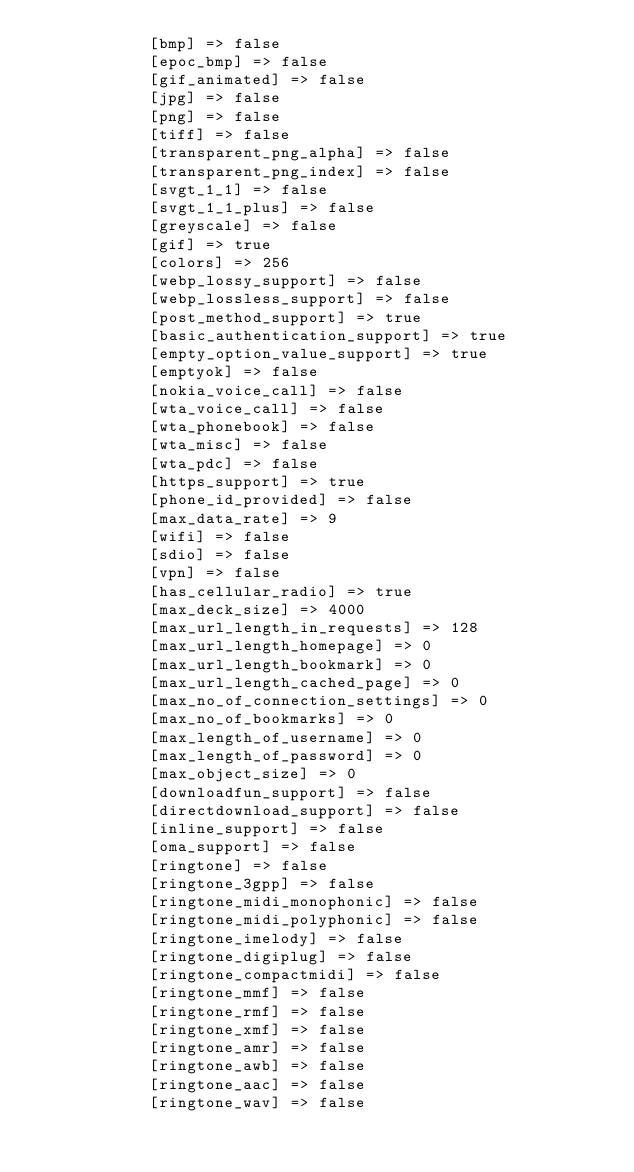<code> <loc_0><loc_0><loc_500><loc_500><_HTML_>            [bmp] => false
            [epoc_bmp] => false
            [gif_animated] => false
            [jpg] => false
            [png] => false
            [tiff] => false
            [transparent_png_alpha] => false
            [transparent_png_index] => false
            [svgt_1_1] => false
            [svgt_1_1_plus] => false
            [greyscale] => false
            [gif] => true
            [colors] => 256
            [webp_lossy_support] => false
            [webp_lossless_support] => false
            [post_method_support] => true
            [basic_authentication_support] => true
            [empty_option_value_support] => true
            [emptyok] => false
            [nokia_voice_call] => false
            [wta_voice_call] => false
            [wta_phonebook] => false
            [wta_misc] => false
            [wta_pdc] => false
            [https_support] => true
            [phone_id_provided] => false
            [max_data_rate] => 9
            [wifi] => false
            [sdio] => false
            [vpn] => false
            [has_cellular_radio] => true
            [max_deck_size] => 4000
            [max_url_length_in_requests] => 128
            [max_url_length_homepage] => 0
            [max_url_length_bookmark] => 0
            [max_url_length_cached_page] => 0
            [max_no_of_connection_settings] => 0
            [max_no_of_bookmarks] => 0
            [max_length_of_username] => 0
            [max_length_of_password] => 0
            [max_object_size] => 0
            [downloadfun_support] => false
            [directdownload_support] => false
            [inline_support] => false
            [oma_support] => false
            [ringtone] => false
            [ringtone_3gpp] => false
            [ringtone_midi_monophonic] => false
            [ringtone_midi_polyphonic] => false
            [ringtone_imelody] => false
            [ringtone_digiplug] => false
            [ringtone_compactmidi] => false
            [ringtone_mmf] => false
            [ringtone_rmf] => false
            [ringtone_xmf] => false
            [ringtone_amr] => false
            [ringtone_awb] => false
            [ringtone_aac] => false
            [ringtone_wav] => false</code> 